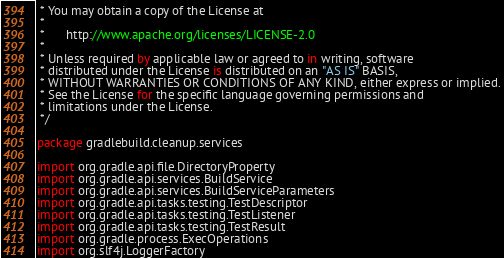<code> <loc_0><loc_0><loc_500><loc_500><_Kotlin_> * You may obtain a copy of the License at
 *
 *      http://www.apache.org/licenses/LICENSE-2.0
 *
 * Unless required by applicable law or agreed to in writing, software
 * distributed under the License is distributed on an "AS IS" BASIS,
 * WITHOUT WARRANTIES OR CONDITIONS OF ANY KIND, either express or implied.
 * See the License for the specific language governing permissions and
 * limitations under the License.
 */

package gradlebuild.cleanup.services

import org.gradle.api.file.DirectoryProperty
import org.gradle.api.services.BuildService
import org.gradle.api.services.BuildServiceParameters
import org.gradle.api.tasks.testing.TestDescriptor
import org.gradle.api.tasks.testing.TestListener
import org.gradle.api.tasks.testing.TestResult
import org.gradle.process.ExecOperations
import org.slf4j.LoggerFactory</code> 